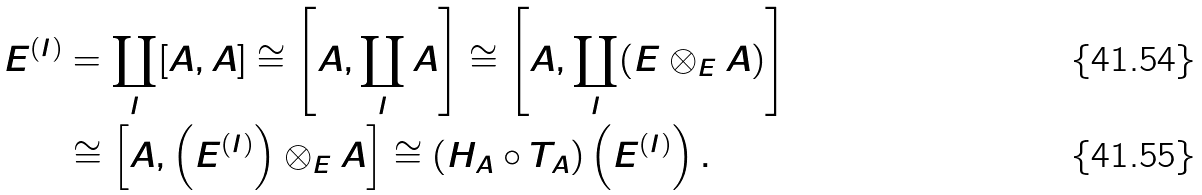<formula> <loc_0><loc_0><loc_500><loc_500>E ^ { ( I ) } & = \coprod _ { I } [ A , A ] \cong \left [ A , \coprod _ { I } A \right ] \cong \left [ A , \coprod _ { I } ( E \otimes _ { E } A ) \right ] \\ & \cong \left [ A , \left ( E ^ { ( I ) } \right ) \otimes _ { E } A \right ] \cong ( H _ { A } \circ T _ { A } ) \left ( E ^ { ( I ) } \right ) .</formula> 